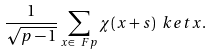<formula> <loc_0><loc_0><loc_500><loc_500>\frac { 1 } { \sqrt { p - 1 } } \sum _ { x \in \ F p } \chi ( x + s ) \ k e t { x } .</formula> 